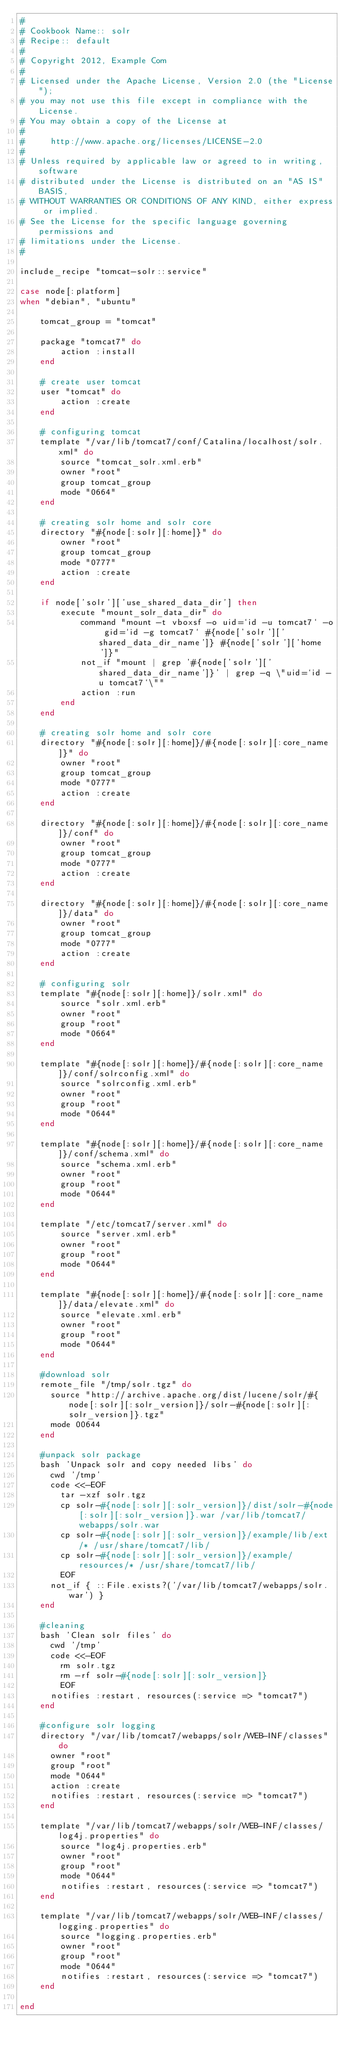Convert code to text. <code><loc_0><loc_0><loc_500><loc_500><_Ruby_>#
# Cookbook Name:: solr
# Recipe:: default
#
# Copyright 2012, Example Com
#
# Licensed under the Apache License, Version 2.0 (the "License");
# you may not use this file except in compliance with the License.
# You may obtain a copy of the License at
# 
#     http://www.apache.org/licenses/LICENSE-2.0
# 
# Unless required by applicable law or agreed to in writing, software
# distributed under the License is distributed on an "AS IS" BASIS,
# WITHOUT WARRANTIES OR CONDITIONS OF ANY KIND, either express or implied.
# See the License for the specific language governing permissions and
# limitations under the License.
#

include_recipe "tomcat-solr::service"

case node[:platform]
when "debian", "ubuntu"

    tomcat_group = "tomcat"

    package "tomcat7" do
        action :install
    end

    # create user tomcat
    user "tomcat" do
        action :create
    end

    # configuring tomcat
    template "/var/lib/tomcat7/conf/Catalina/localhost/solr.xml" do
        source "tomcat_solr.xml.erb"
        owner "root"
        group tomcat_group
        mode "0664"
    end

    # creating solr home and solr core
    directory "#{node[:solr][:home]}" do
        owner "root"
        group tomcat_group
        mode "0777"
        action :create
    end

    if node['solr']['use_shared_data_dir'] then
        execute "mount_solr_data_dir" do
            command "mount -t vboxsf -o uid=`id -u tomcat7` -o gid=`id -g tomcat7` #{node['solr']['shared_data_dir_name']} #{node['solr']['home']}"
            not_if "mount | grep '#{node['solr']['shared_data_dir_name']}' | grep -q \"uid=`id -u tomcat7`\""
            action :run
        end
    end

    # creating solr home and solr core
    directory "#{node[:solr][:home]}/#{node[:solr][:core_name]}" do
        owner "root"
        group tomcat_group
        mode "0777"
        action :create
    end

    directory "#{node[:solr][:home]}/#{node[:solr][:core_name]}/conf" do
        owner "root"
        group tomcat_group
        mode "0777"
        action :create
    end

    directory "#{node[:solr][:home]}/#{node[:solr][:core_name]}/data" do
        owner "root"
        group tomcat_group
        mode "0777"
        action :create
    end

    # configuring solr
    template "#{node[:solr][:home]}/solr.xml" do
        source "solr.xml.erb"
        owner "root"
        group "root"
        mode "0664" 
    end

    template "#{node[:solr][:home]}/#{node[:solr][:core_name]}/conf/solrconfig.xml" do
        source "solrconfig.xml.erb"
        owner "root"
        group "root"
        mode "0644"
    end

    template "#{node[:solr][:home]}/#{node[:solr][:core_name]}/conf/schema.xml" do
        source "schema.xml.erb"
        owner "root"
        group "root"
        mode "0644"
    end

    template "/etc/tomcat7/server.xml" do
        source "server.xml.erb"
        owner "root"
        group "root"
        mode "0644"
    end

    template "#{node[:solr][:home]}/#{node[:solr][:core_name]}/data/elevate.xml" do
        source "elevate.xml.erb"
        owner "root"
        group "root"
        mode "0644"
    end

    #download solr
    remote_file "/tmp/solr.tgz" do
      source "http://archive.apache.org/dist/lucene/solr/#{node[:solr][:solr_version]}/solr-#{node[:solr][:solr_version]}.tgz"
      mode 00644
    end

    #unpack solr package
    bash 'Unpack solr and copy needed libs' do
      cwd '/tmp'
      code <<-EOF
        tar -xzf solr.tgz
        cp solr-#{node[:solr][:solr_version]}/dist/solr-#{node[:solr][:solr_version]}.war /var/lib/tomcat7/webapps/solr.war
        cp solr-#{node[:solr][:solr_version]}/example/lib/ext/* /usr/share/tomcat7/lib/
        cp solr-#{node[:solr][:solr_version]}/example/resources/* /usr/share/tomcat7/lib/
        EOF
      not_if { ::File.exists?('/var/lib/tomcat7/webapps/solr.war') }
    end

    #cleaning
    bash 'Clean solr files' do
      cwd '/tmp'
      code <<-EOF
        rm solr.tgz
        rm -rf solr-#{node[:solr][:solr_version]}
        EOF
      notifies :restart, resources(:service => "tomcat7")
    end

    #configure solr logging
    directory "/var/lib/tomcat7/webapps/solr/WEB-INF/classes" do
      owner "root"
      group "root"
      mode "0644"
      action :create
      notifies :restart, resources(:service => "tomcat7")
    end

    template "/var/lib/tomcat7/webapps/solr/WEB-INF/classes/log4j.properties" do
        source "log4j.properties.erb"
        owner "root"
        group "root"
        mode "0644"
        notifies :restart, resources(:service => "tomcat7")
    end

    template "/var/lib/tomcat7/webapps/solr/WEB-INF/classes/logging.properties" do
        source "logging.properties.erb"
        owner "root"
        group "root"
        mode "0644"
        notifies :restart, resources(:service => "tomcat7")
    end

end
</code> 